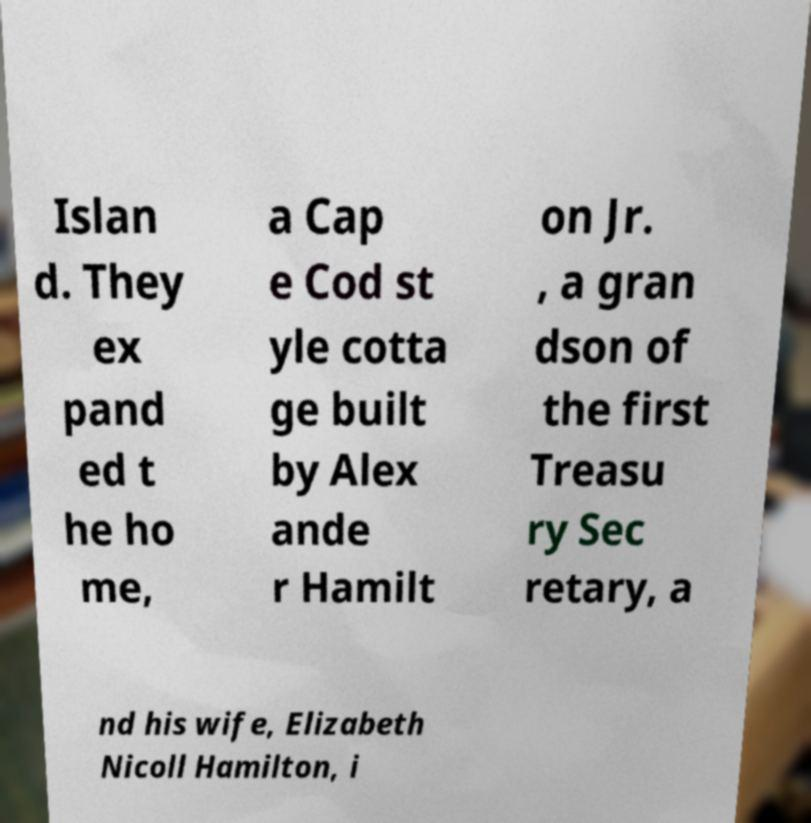Can you read and provide the text displayed in the image?This photo seems to have some interesting text. Can you extract and type it out for me? Islan d. They ex pand ed t he ho me, a Cap e Cod st yle cotta ge built by Alex ande r Hamilt on Jr. , a gran dson of the first Treasu ry Sec retary, a nd his wife, Elizabeth Nicoll Hamilton, i 